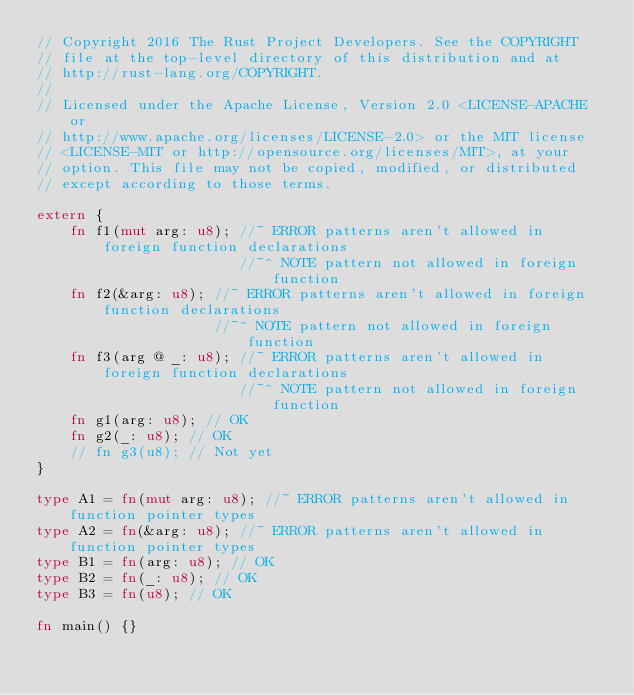<code> <loc_0><loc_0><loc_500><loc_500><_Rust_>// Copyright 2016 The Rust Project Developers. See the COPYRIGHT
// file at the top-level directory of this distribution and at
// http://rust-lang.org/COPYRIGHT.
//
// Licensed under the Apache License, Version 2.0 <LICENSE-APACHE or
// http://www.apache.org/licenses/LICENSE-2.0> or the MIT license
// <LICENSE-MIT or http://opensource.org/licenses/MIT>, at your
// option. This file may not be copied, modified, or distributed
// except according to those terms.

extern {
    fn f1(mut arg: u8); //~ ERROR patterns aren't allowed in foreign function declarations
                        //~^ NOTE pattern not allowed in foreign function
    fn f2(&arg: u8); //~ ERROR patterns aren't allowed in foreign function declarations
                     //~^ NOTE pattern not allowed in foreign function
    fn f3(arg @ _: u8); //~ ERROR patterns aren't allowed in foreign function declarations
                        //~^ NOTE pattern not allowed in foreign function
    fn g1(arg: u8); // OK
    fn g2(_: u8); // OK
    // fn g3(u8); // Not yet
}

type A1 = fn(mut arg: u8); //~ ERROR patterns aren't allowed in function pointer types
type A2 = fn(&arg: u8); //~ ERROR patterns aren't allowed in function pointer types
type B1 = fn(arg: u8); // OK
type B2 = fn(_: u8); // OK
type B3 = fn(u8); // OK

fn main() {}
</code> 